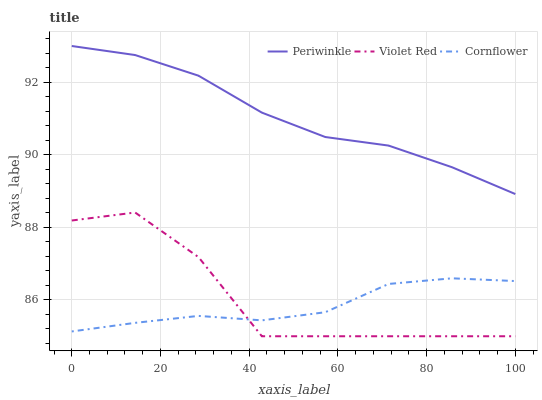Does Cornflower have the minimum area under the curve?
Answer yes or no. Yes. Does Periwinkle have the maximum area under the curve?
Answer yes or no. Yes. Does Violet Red have the minimum area under the curve?
Answer yes or no. No. Does Violet Red have the maximum area under the curve?
Answer yes or no. No. Is Periwinkle the smoothest?
Answer yes or no. Yes. Is Violet Red the roughest?
Answer yes or no. Yes. Is Violet Red the smoothest?
Answer yes or no. No. Is Periwinkle the roughest?
Answer yes or no. No. Does Violet Red have the lowest value?
Answer yes or no. Yes. Does Periwinkle have the lowest value?
Answer yes or no. No. Does Periwinkle have the highest value?
Answer yes or no. Yes. Does Violet Red have the highest value?
Answer yes or no. No. Is Cornflower less than Periwinkle?
Answer yes or no. Yes. Is Periwinkle greater than Violet Red?
Answer yes or no. Yes. Does Cornflower intersect Violet Red?
Answer yes or no. Yes. Is Cornflower less than Violet Red?
Answer yes or no. No. Is Cornflower greater than Violet Red?
Answer yes or no. No. Does Cornflower intersect Periwinkle?
Answer yes or no. No. 